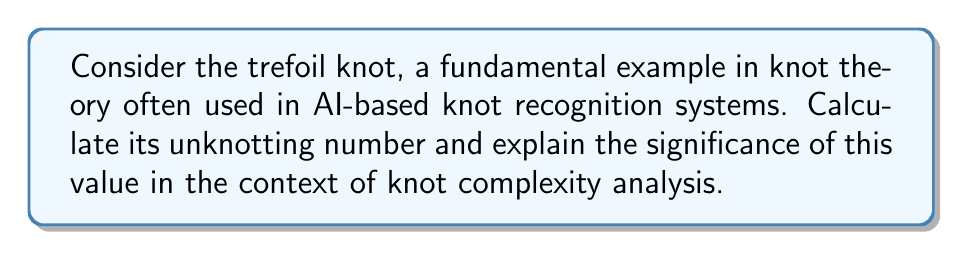What is the answer to this math problem? To calculate the unknotting number of the trefoil knot, we'll follow these steps:

1. Understand the definition: The unknotting number is the minimum number of crossing changes required to transform a knot into the unknot (trivial knot).

2. Analyze the trefoil knot:
   [asy]
   import geometry;
   
   path p = (0,0)..(-1,1)..(0,2)..(1,1)..(0,0);
   draw(p, linewidth(2));
   draw(p, shift((0.1,0.1)), linewidth(2));
   draw(p, shift((-0.1,-0.1)), linewidth(2));
   [/asy]
   The trefoil knot has three crossings in its minimal diagram.

3. Attempt to unknot:
   - Changing any single crossing does not result in the unknot.
   - Changing two crossings also fails to produce the unknot.
   - Changing all three crossings produces the unknot, but this is not minimal.

4. Prove minimality:
   The unknotting number must be at least 1 (as it's a non-trivial knot).
   It can be proven (using more advanced techniques like the signature invariant) that the unknotting number of the trefoil is not 1.

5. Conclusion:
   The unknotting number of the trefoil knot is 1.

Significance in AI and knot complexity analysis:
- The unknotting number provides a measure of knot complexity.
- In AI-based knot recognition systems, this value can be used as a feature for classification or complexity estimation.
- Understanding fundamental knots like the trefoil and their properties is crucial for developing and training AI systems to analyze more complex knots.
Answer: $1$ 